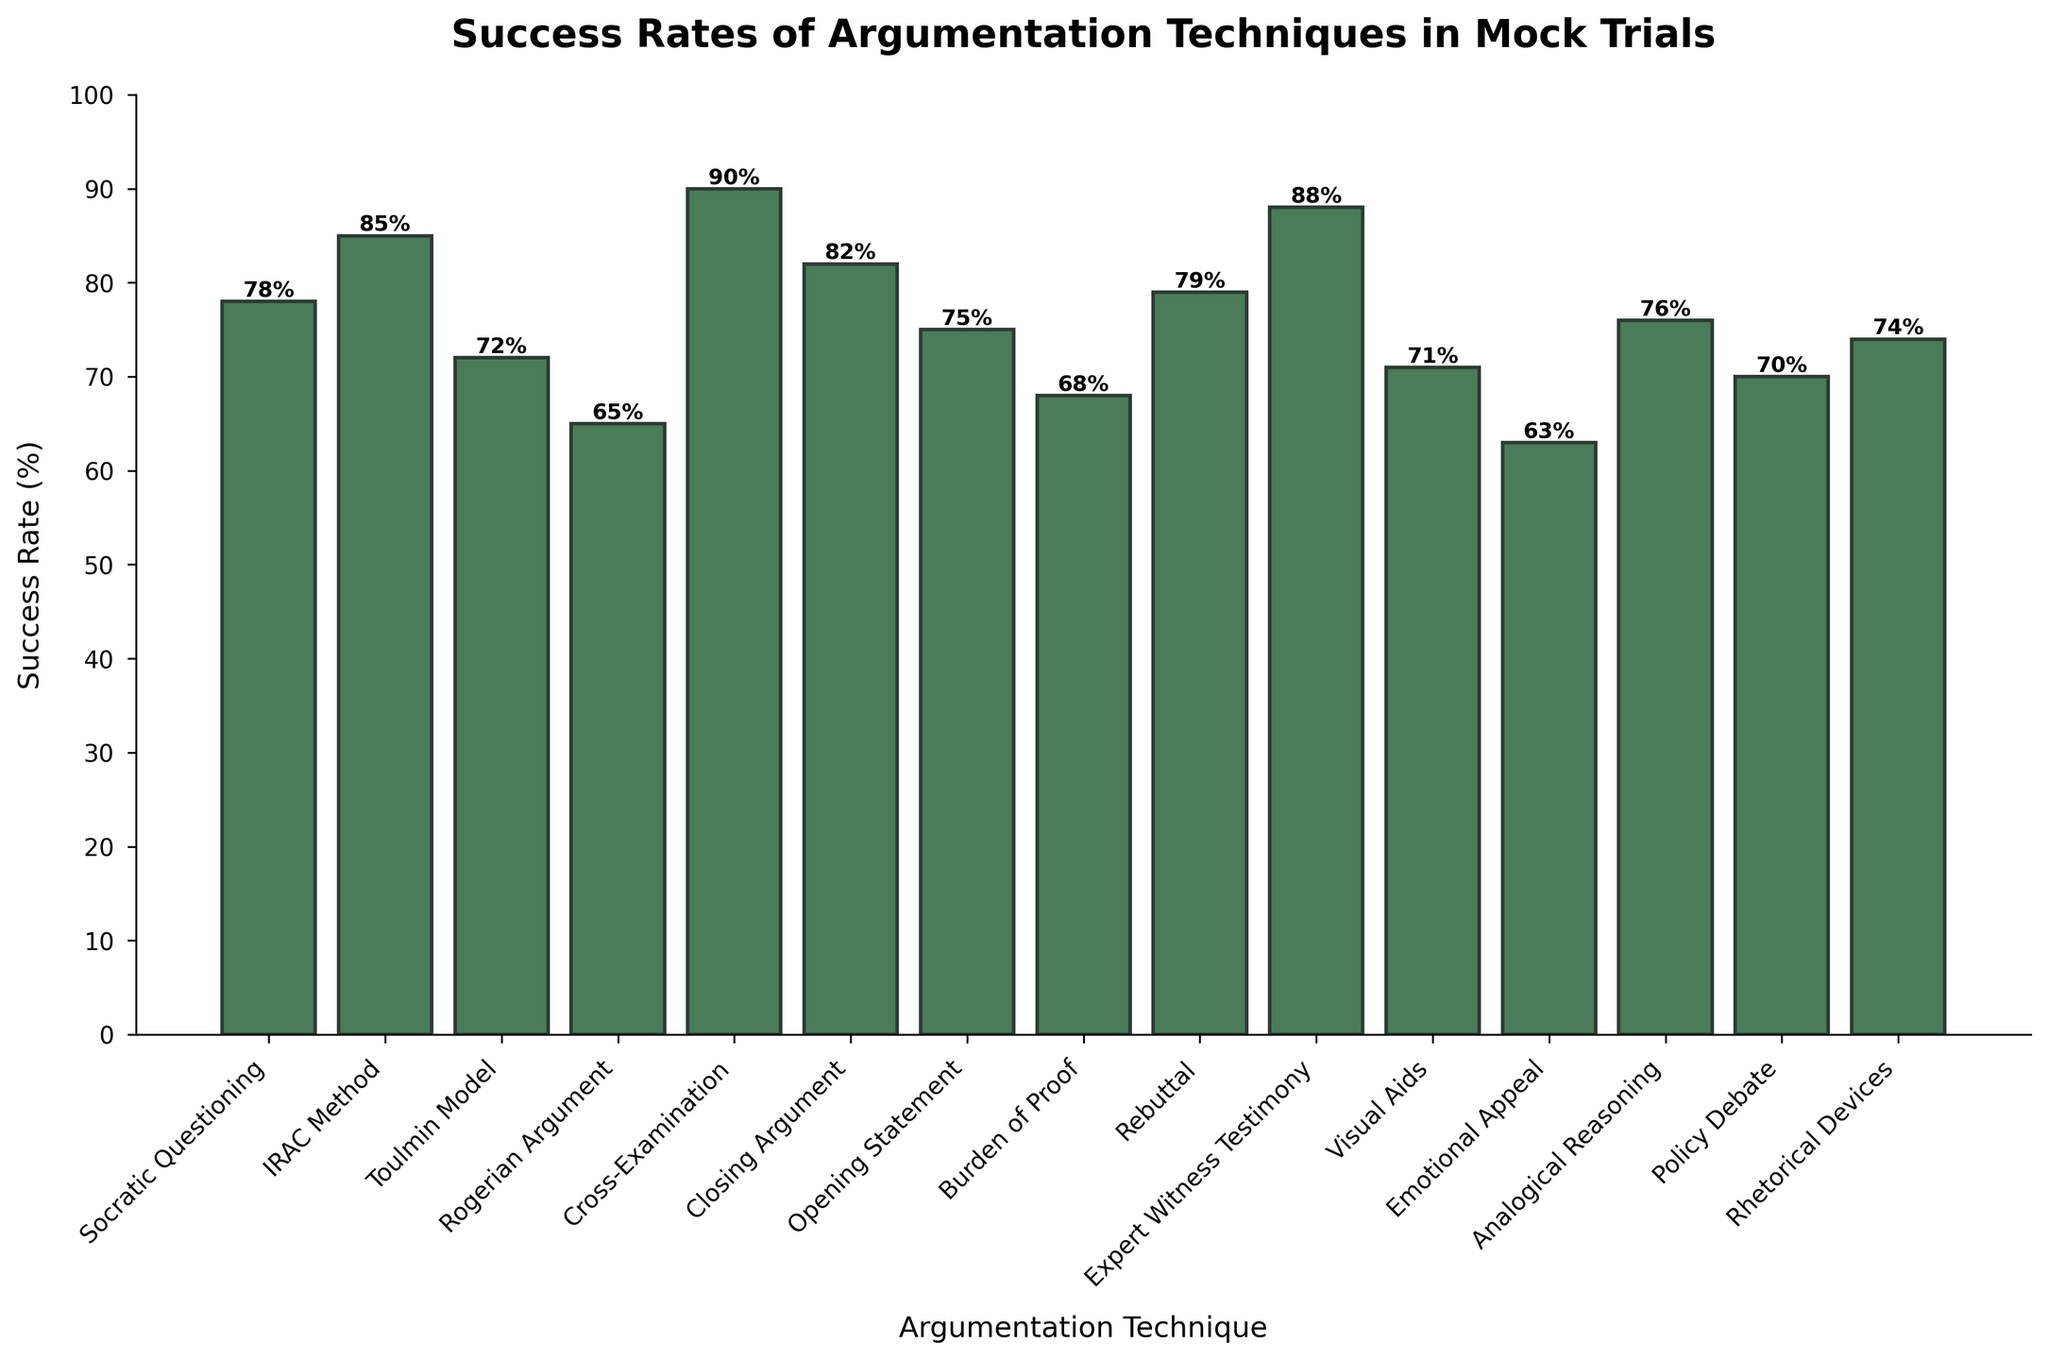Which argumentation technique has the highest success rate? In the bar chart, look for the tallest bar. The tallest bar represents the Cross-Examination technique.
Answer: Cross-Examination Which technique has a success rate of 85%? Look for the bar with a height of 85% in the chart. The corresponding label for that bar is the IRAC Method.
Answer: IRAC Method How much higher is the success rate of Cross-Examination compared to Rogerian Argument? The success rate of Cross-Examination is 90%, and the Rogerian Argument is 65%. Calculate the difference: 90% - 65% = 25%.
Answer: 25% Which techniques have a success rate below 70%? Identify the bars that are below the 70% mark. The corresponding techniques are Rogerian Argument, Emotional Appeal, Policy Debate, and Burden of Proof.
Answer: Rogerian Argument, Emotional Appeal, Policy Debate, Burden of Proof What is the average success rate of all the techniques? Sum all the success rates (78 + 85 + 72 + 65 + 90 + 82 + 75 + 68 + 79 + 88 + 71 + 63 + 76 + 70 + 74) and divide by the number of techniques (15). Total sum = 1166; 1166 / 15 ≈ 77.73%.
Answer: 77.73% Which technique has a success rate closest to the average success rate? The average success rate is 77.73%. Compare this with the success rates of all techniques. The closest value is 76% for Analogical Reasoning.
Answer: Analogical Reasoning Which argumentation technique has a success rate just above 70%? Look for the bar just above the 70% mark. The corresponding label is Visual Aids with a success rate of 71%.
Answer: Visual Aids What's the difference between the highest and the lowest success rates? The highest success rate is 90% (Cross-Examination) and the lowest is 63% (Emotional Appeal). Calculate the difference: 90% - 63% = 27%.
Answer: 27% How does the success rate of Expert Witness Testimony compare to that of Closing Argument? Expert Witness Testimony has a success rate of 88% and Closing Argument has 82%. Since 88% is greater than 82%, Expert Witness Testimony has a higher success rate.
Answer: Expert Witness Testimony is higher What is the combined success rate of the techniques starting with "R"? Identify the techniques: Rogerian Argument (65%), Rebuttal (79%), and Rhetorical Devices (74%). Calculate the total: 65 + 79 + 74 = 218%.
Answer: 218% 